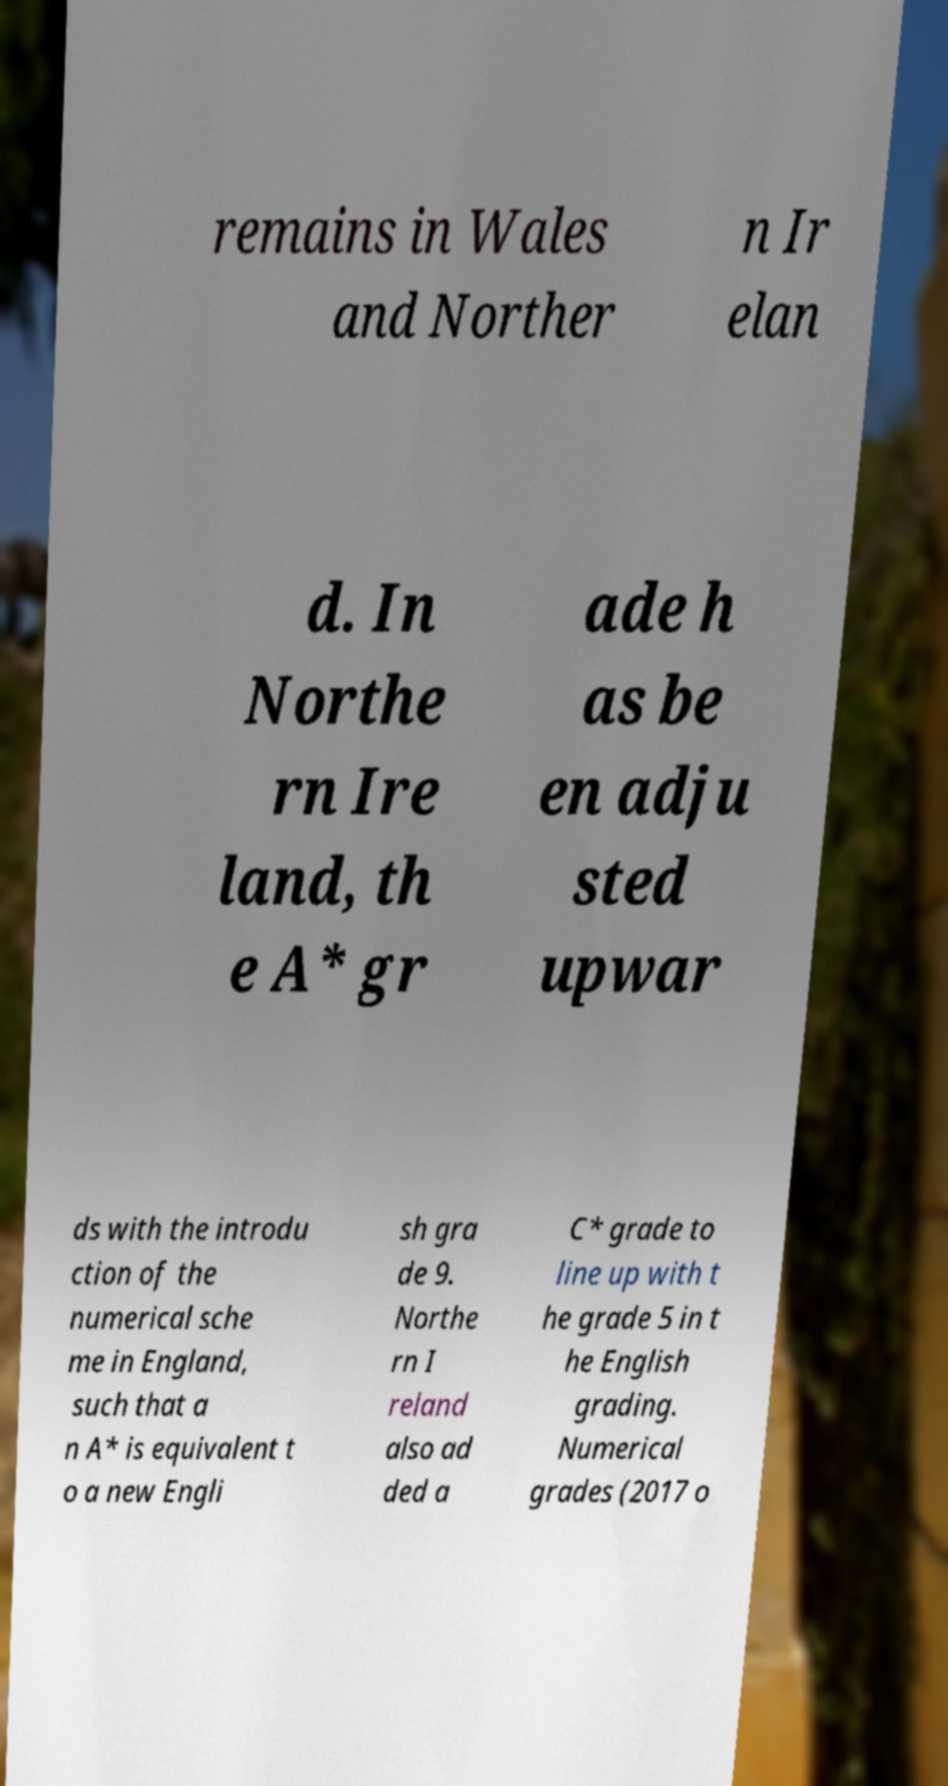What messages or text are displayed in this image? I need them in a readable, typed format. remains in Wales and Norther n Ir elan d. In Northe rn Ire land, th e A* gr ade h as be en adju sted upwar ds with the introdu ction of the numerical sche me in England, such that a n A* is equivalent t o a new Engli sh gra de 9. Northe rn I reland also ad ded a C* grade to line up with t he grade 5 in t he English grading. Numerical grades (2017 o 